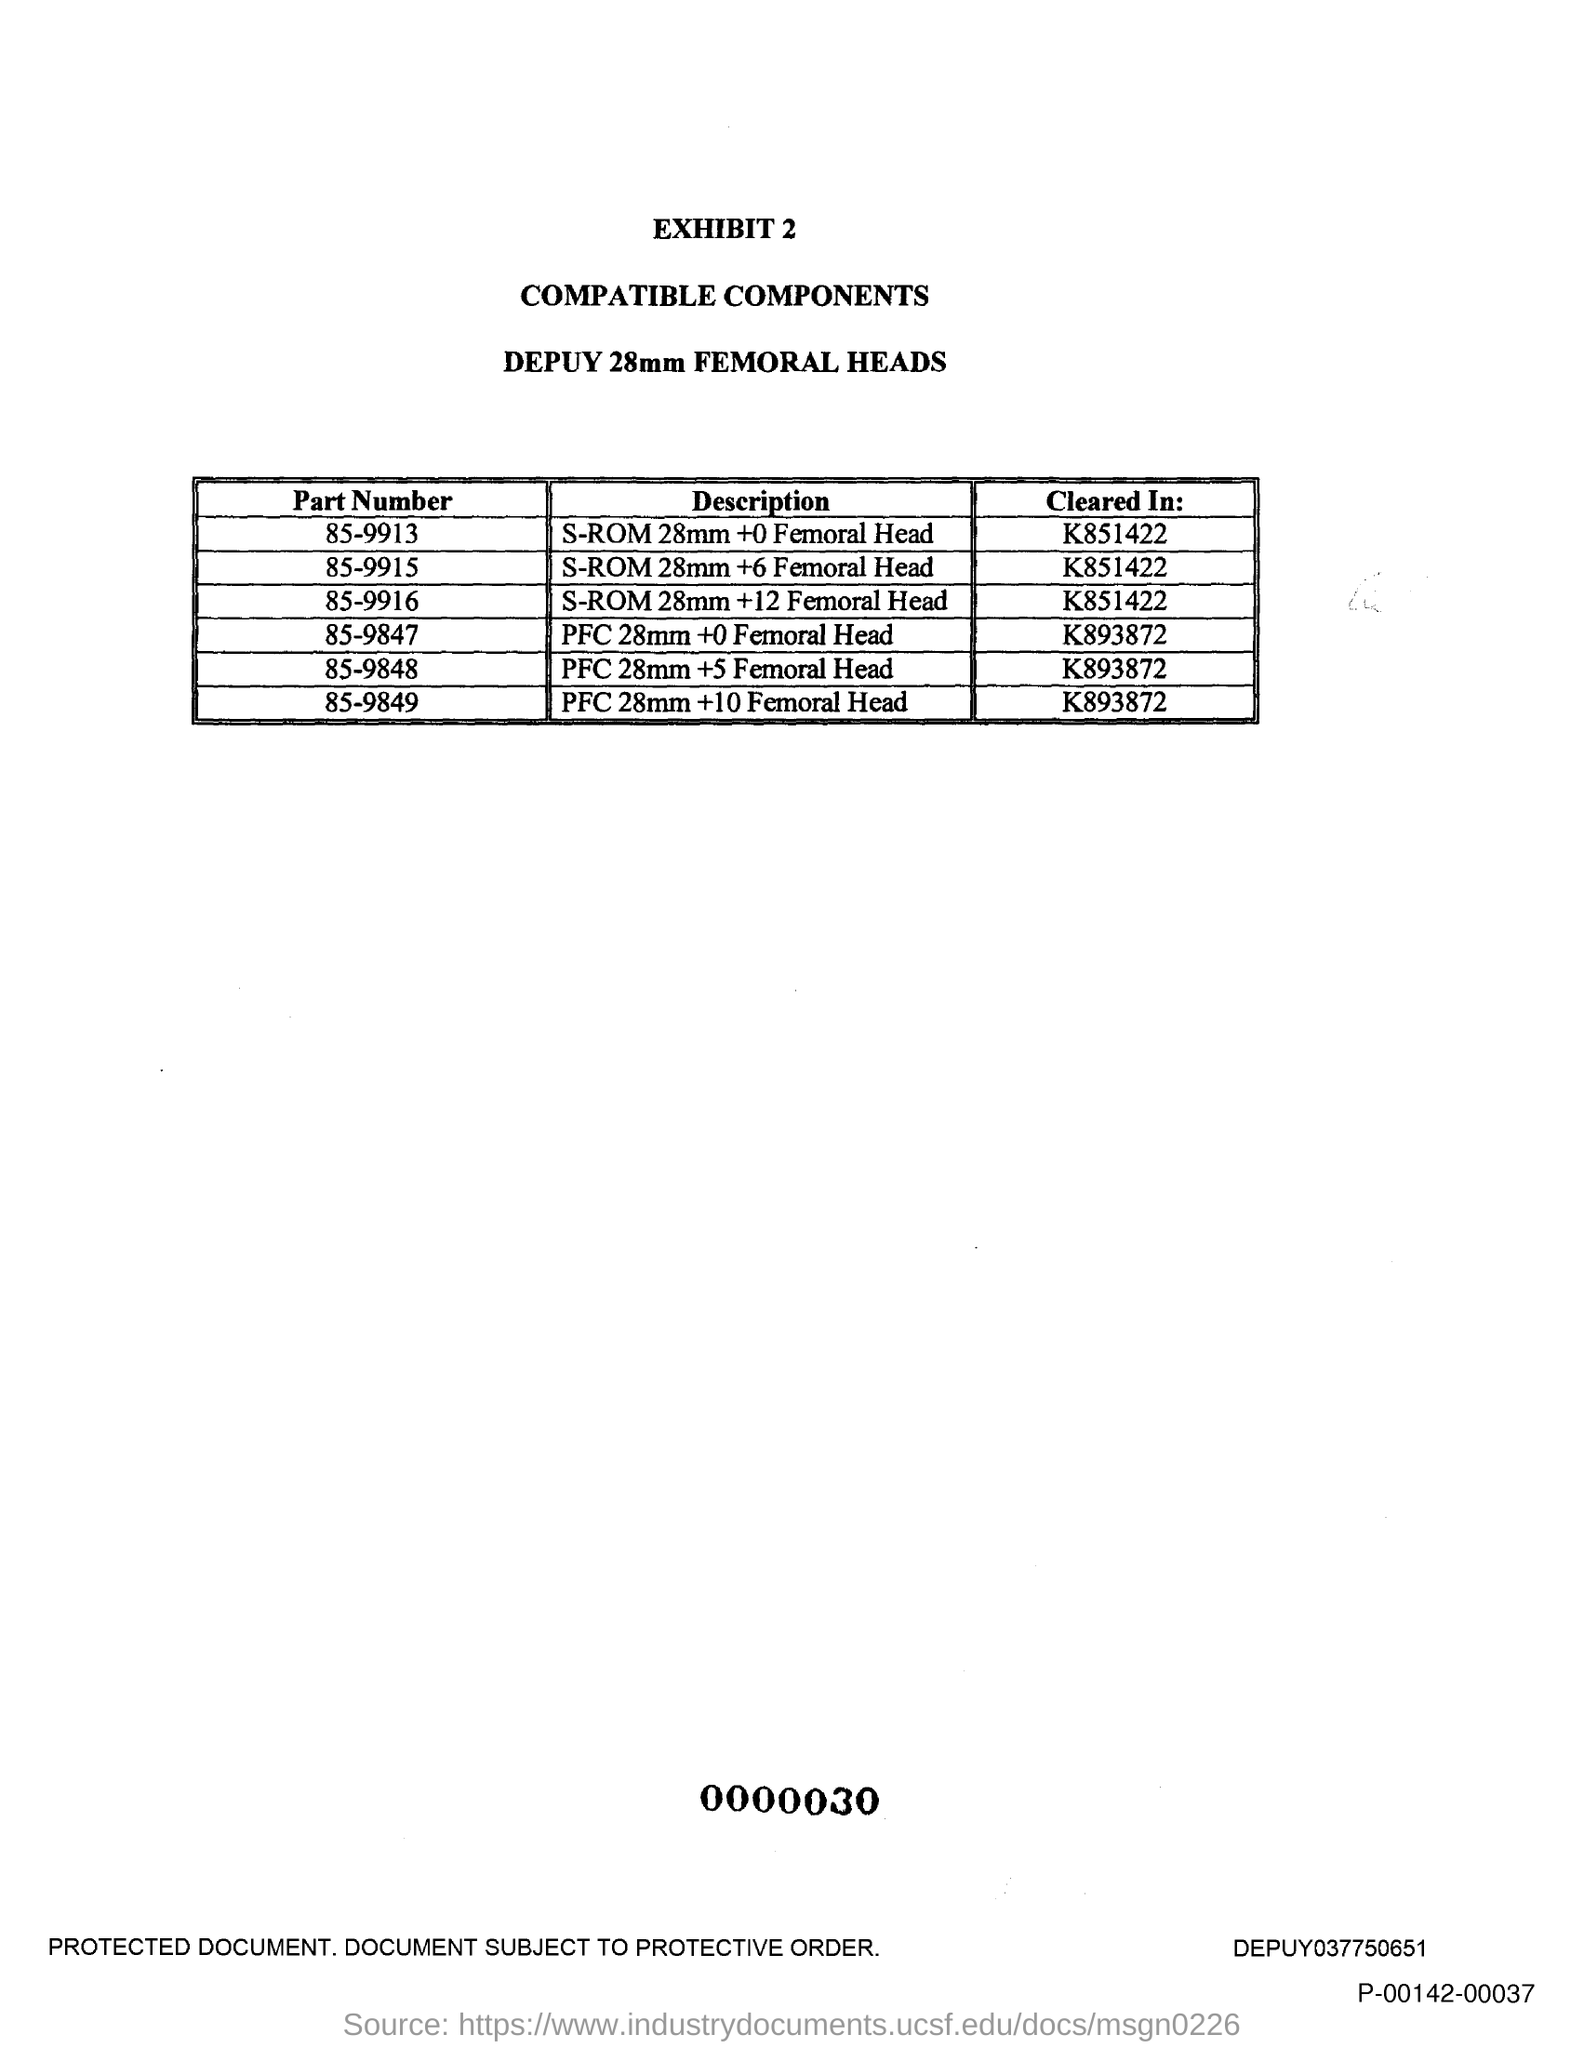What is the second title in this document?
Your answer should be very brief. COMPATIBLE COMPONENTS. 